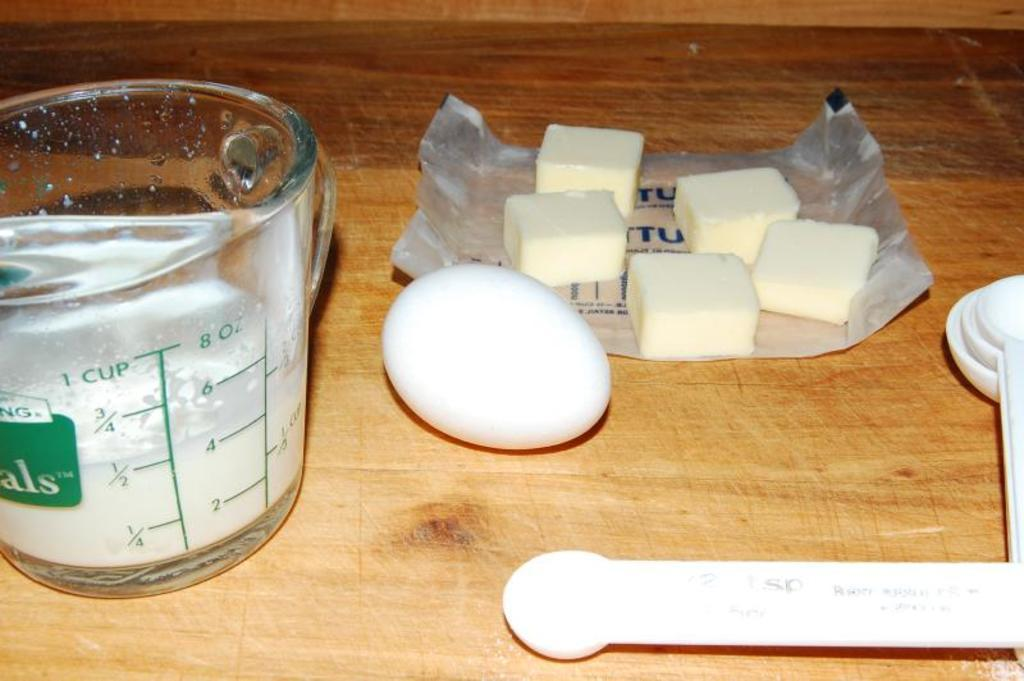<image>
Summarize the visual content of the image. One egg, five pats of butter and a measuring cup filled with a 1/2 cup milk. 